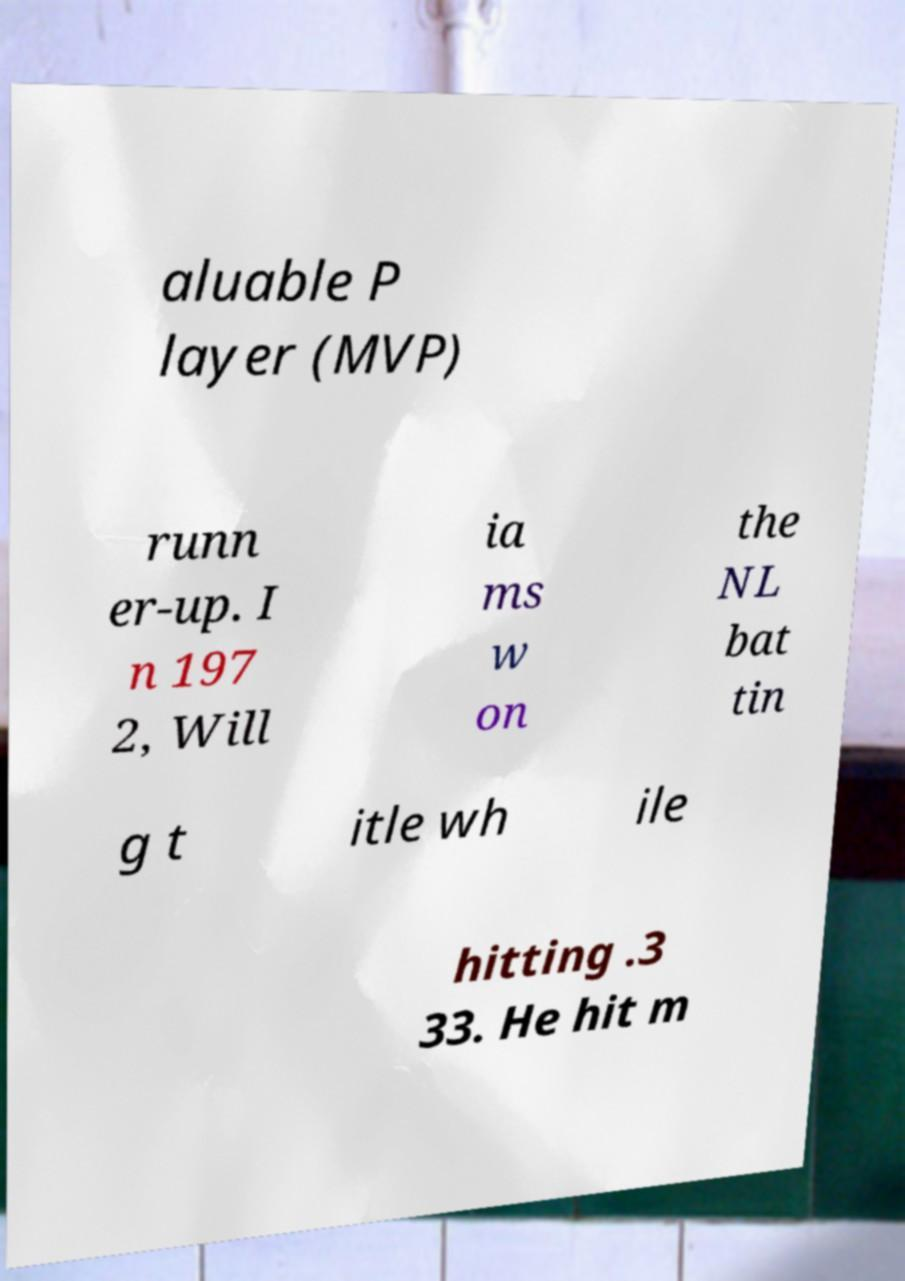Could you extract and type out the text from this image? aluable P layer (MVP) runn er-up. I n 197 2, Will ia ms w on the NL bat tin g t itle wh ile hitting .3 33. He hit m 